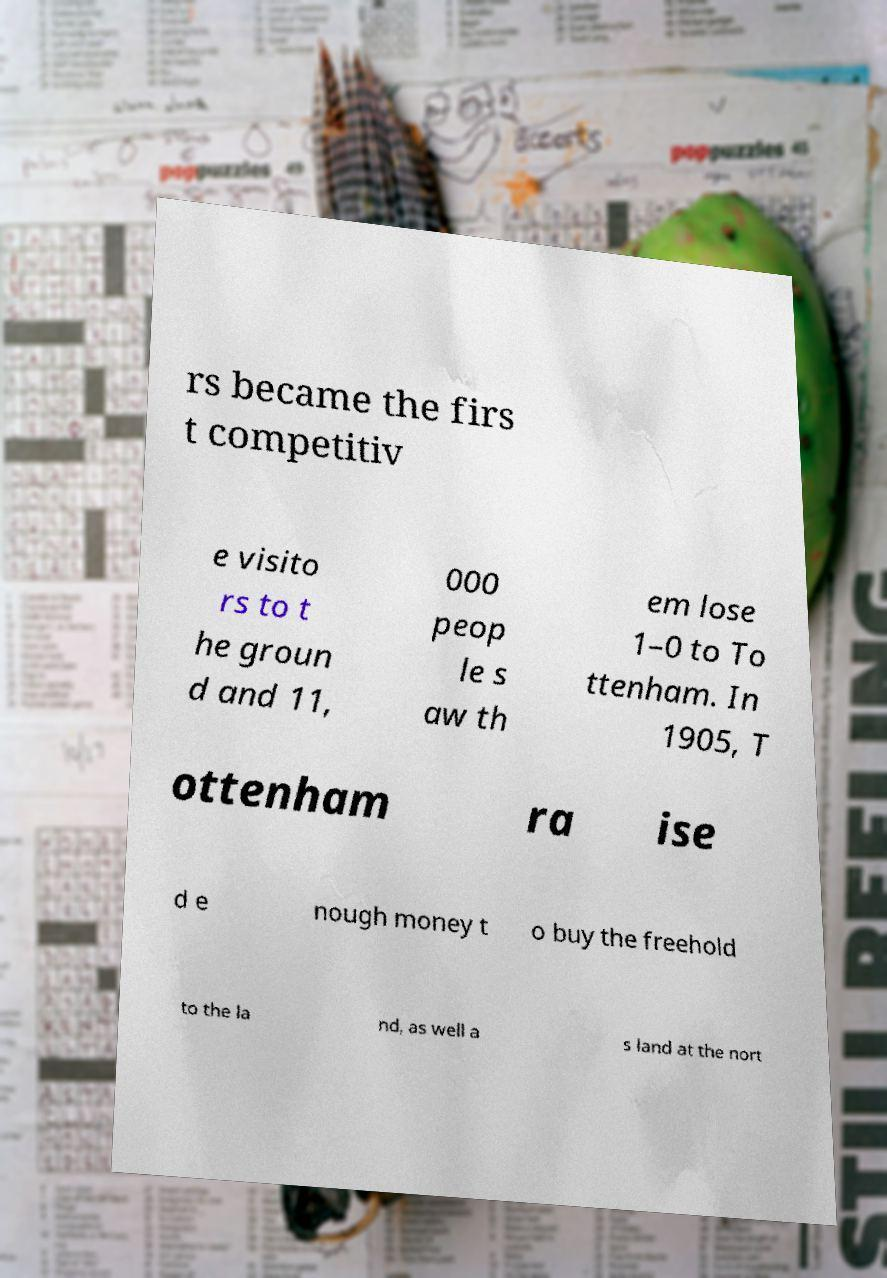Can you read and provide the text displayed in the image?This photo seems to have some interesting text. Can you extract and type it out for me? rs became the firs t competitiv e visito rs to t he groun d and 11, 000 peop le s aw th em lose 1–0 to To ttenham. In 1905, T ottenham ra ise d e nough money t o buy the freehold to the la nd, as well a s land at the nort 